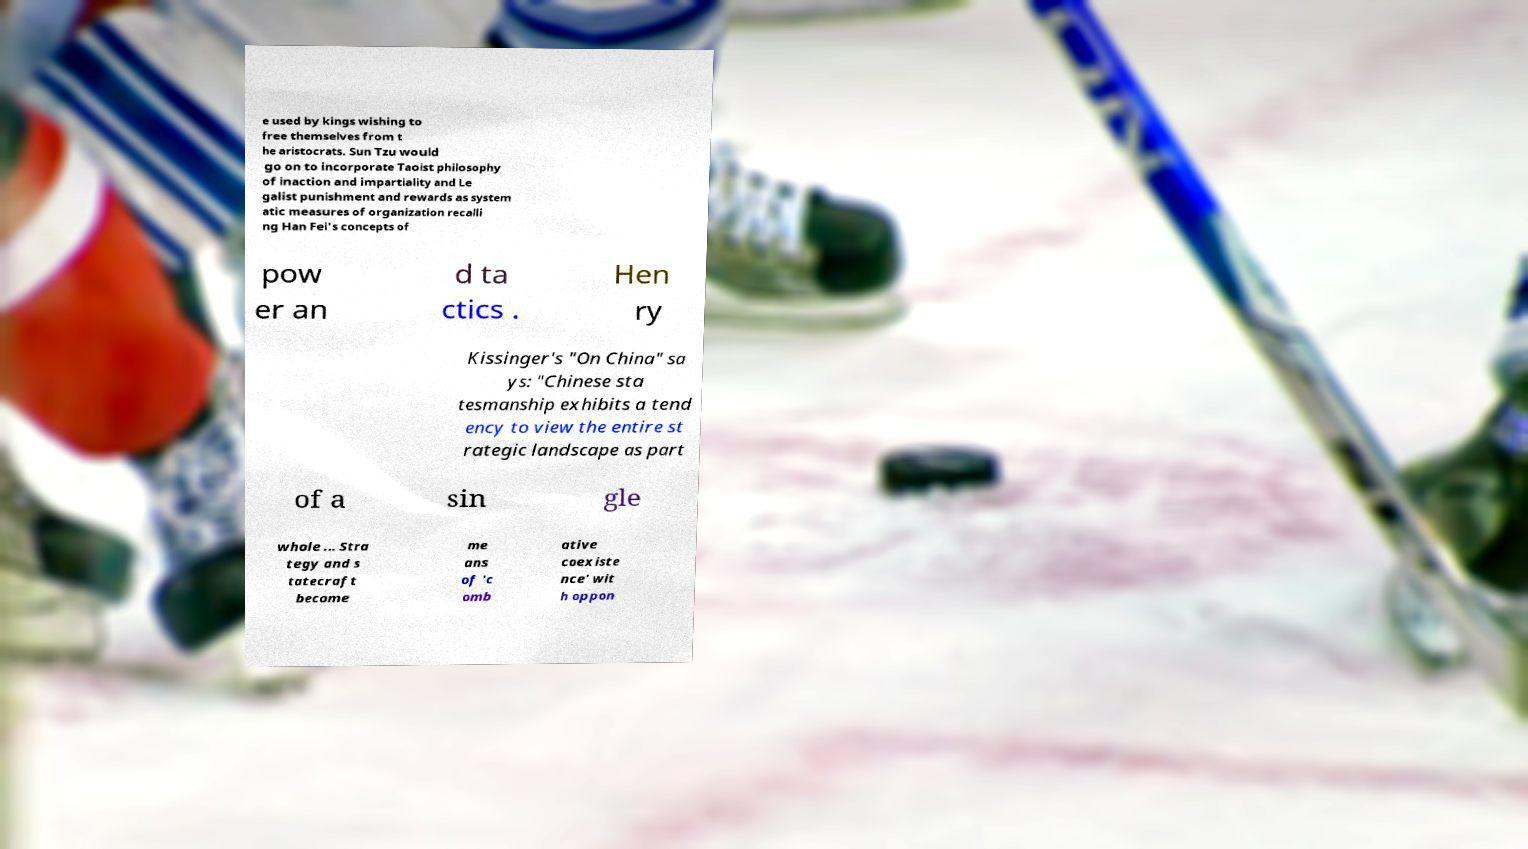I need the written content from this picture converted into text. Can you do that? e used by kings wishing to free themselves from t he aristocrats. Sun Tzu would go on to incorporate Taoist philosophy of inaction and impartiality and Le galist punishment and rewards as system atic measures of organization recalli ng Han Fei's concepts of pow er an d ta ctics . Hen ry Kissinger's "On China" sa ys: "Chinese sta tesmanship exhibits a tend ency to view the entire st rategic landscape as part of a sin gle whole ... Stra tegy and s tatecraft become me ans of 'c omb ative coexiste nce' wit h oppon 